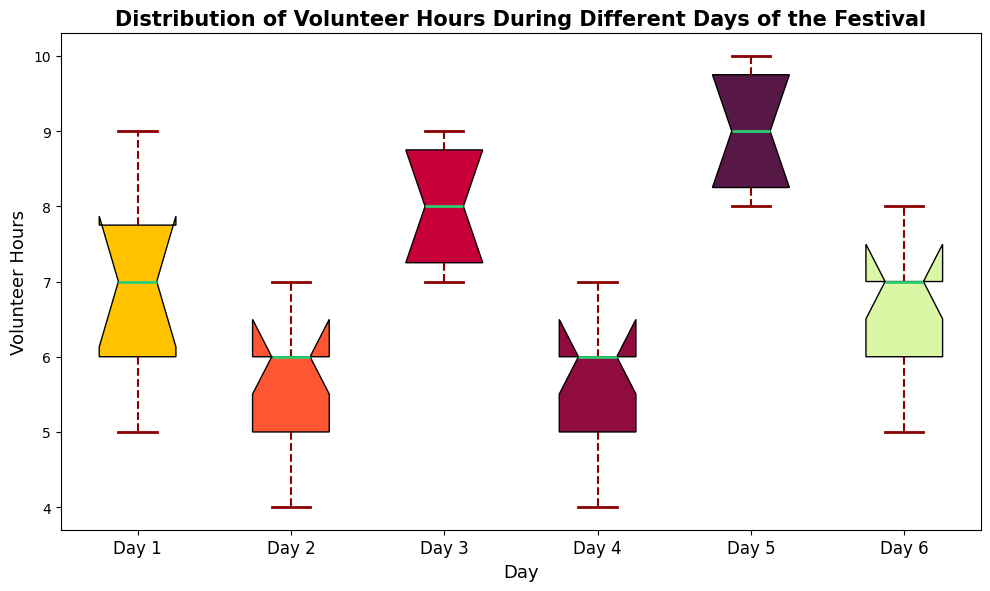What is the median volunteer hours for Day 1? The median is the middle value when the numbers are ordered. The sorted hours for Day 1 are [5, 5, 6, 6, 7, 7, 7, 8, 8, 9]. The median is the average of the 5th and 6th values, which are both 7.
Answer: 7 Which day has the highest median volunteer hours? By observing the box plots, we can compare the medians marked by the line inside each box. Day 5 has the highest median.
Answer: Day 5 What is the interquartile range (IQR) for Day 3? The IQR is the difference between the 75th percentile (Q3) and the 25th percentile (Q1). For Day 3, Q3 is the top of the box and Q1 is the bottom of the box. The values are 9 and 7, respectively, so IQR = 9 - 7.
Answer: 2 On which day is the variation in volunteer hours the smallest? The variation is smallest when the box is least spread out. Day 4 has the smallest box plot, indicating the smallest variation.
Answer: Day 4 Compare the median volunteer hours for Day 2 and Day 6. Which day has the higher median? By examining the box plots, you can see that the line inside the box for Day 6 is higher than that for Day 2. Therefore, Day 6 has a higher median volunteer hours.
Answer: Day 6 Are there any outliers in the volunteer hours data for any day of the festival? Outliers are represented by dots outside the whiskers in a box plot. Observing the plot, there are no dots outside the whiskers for any day, indicating no outliers.
Answer: No Which day shows the maximum value of volunteer hours? The maximum value is represented by the top whisker. Observing the plot, Day 5 shows the highest whisker, reaching 10 hours.
Answer: Day 5 Compare the range of volunteer hours for Day 1 and Day 4. Which day has a wider range? The range is the difference between the maximum and minimum values, represented by the whiskers. For Day 1, it's 9 - 5 = 4. For Day 4, it's 7 - 4 = 3. Therefore, Day 1 has a wider range.
Answer: Day 1 On which day did volunteers work the fewest hours on average? The average is roughly indicated by the median. Day 2 has the lowest median, so volunteers worked the fewest hours on average on this day.
Answer: Day 2 Is the median volunteer hours on Day 6 higher than the interquartile range (IQR) for Day 2? The median for Day 6 is determined by the line inside its box, which is approximately 7. For Day 2, the IQR is Q3 - Q1 = 6 - 5 = 1. Thus, 7 > 1.
Answer: Yes 